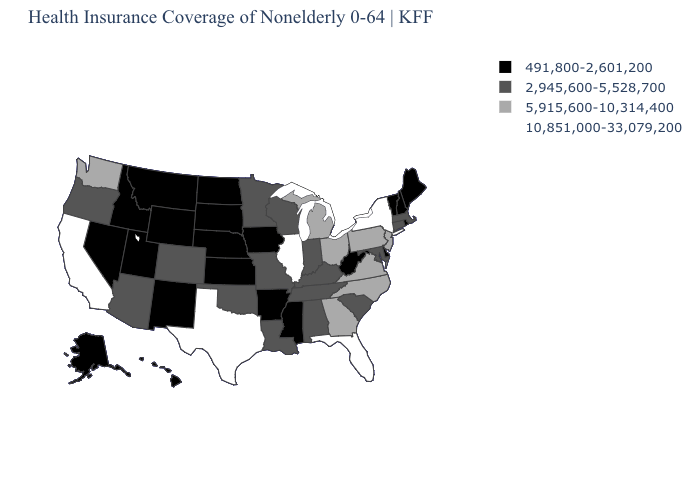What is the value of Illinois?
Be succinct. 10,851,000-33,079,200. Name the states that have a value in the range 491,800-2,601,200?
Short answer required. Alaska, Arkansas, Delaware, Hawaii, Idaho, Iowa, Kansas, Maine, Mississippi, Montana, Nebraska, Nevada, New Hampshire, New Mexico, North Dakota, Rhode Island, South Dakota, Utah, Vermont, West Virginia, Wyoming. Name the states that have a value in the range 2,945,600-5,528,700?
Give a very brief answer. Alabama, Arizona, Colorado, Connecticut, Indiana, Kentucky, Louisiana, Maryland, Massachusetts, Minnesota, Missouri, Oklahoma, Oregon, South Carolina, Tennessee, Wisconsin. Is the legend a continuous bar?
Concise answer only. No. What is the value of Michigan?
Give a very brief answer. 5,915,600-10,314,400. Among the states that border Wisconsin , which have the lowest value?
Short answer required. Iowa. What is the lowest value in states that border Iowa?
Keep it brief. 491,800-2,601,200. What is the value of Maryland?
Quick response, please. 2,945,600-5,528,700. Does Vermont have the lowest value in the USA?
Short answer required. Yes. Does the map have missing data?
Short answer required. No. Which states hav the highest value in the MidWest?
Quick response, please. Illinois. Name the states that have a value in the range 5,915,600-10,314,400?
Be succinct. Georgia, Michigan, New Jersey, North Carolina, Ohio, Pennsylvania, Virginia, Washington. Among the states that border Iowa , does Illinois have the lowest value?
Keep it brief. No. What is the value of Nebraska?
Give a very brief answer. 491,800-2,601,200. Does Maine have a lower value than Alaska?
Quick response, please. No. 